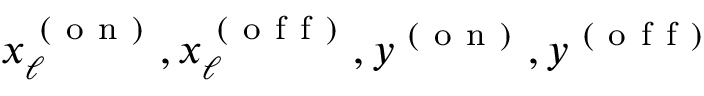<formula> <loc_0><loc_0><loc_500><loc_500>x _ { \ell } ^ { ( o n ) } , x _ { \ell } ^ { ( o f f ) } , y ^ { ( o n ) } , y ^ { ( o f f ) }</formula> 